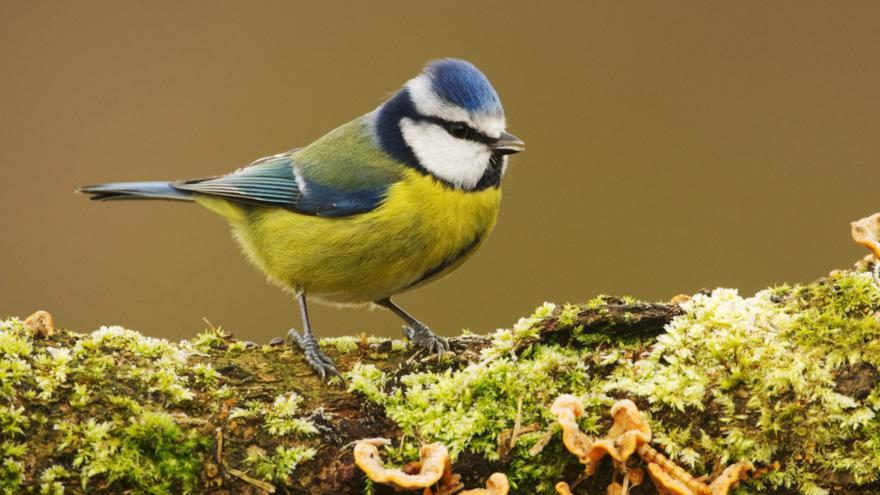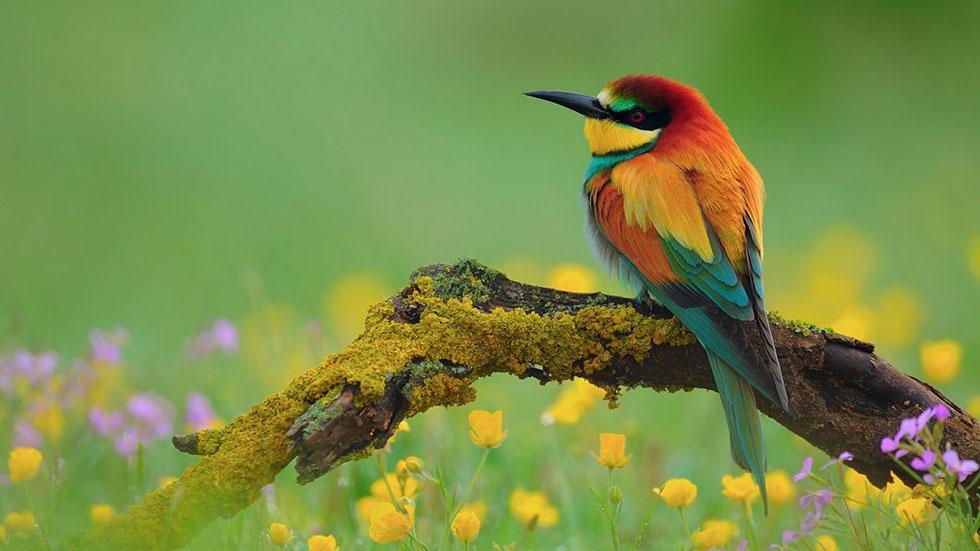The first image is the image on the left, the second image is the image on the right. Examine the images to the left and right. Is the description "There are three birds" accurate? Answer yes or no. No. 